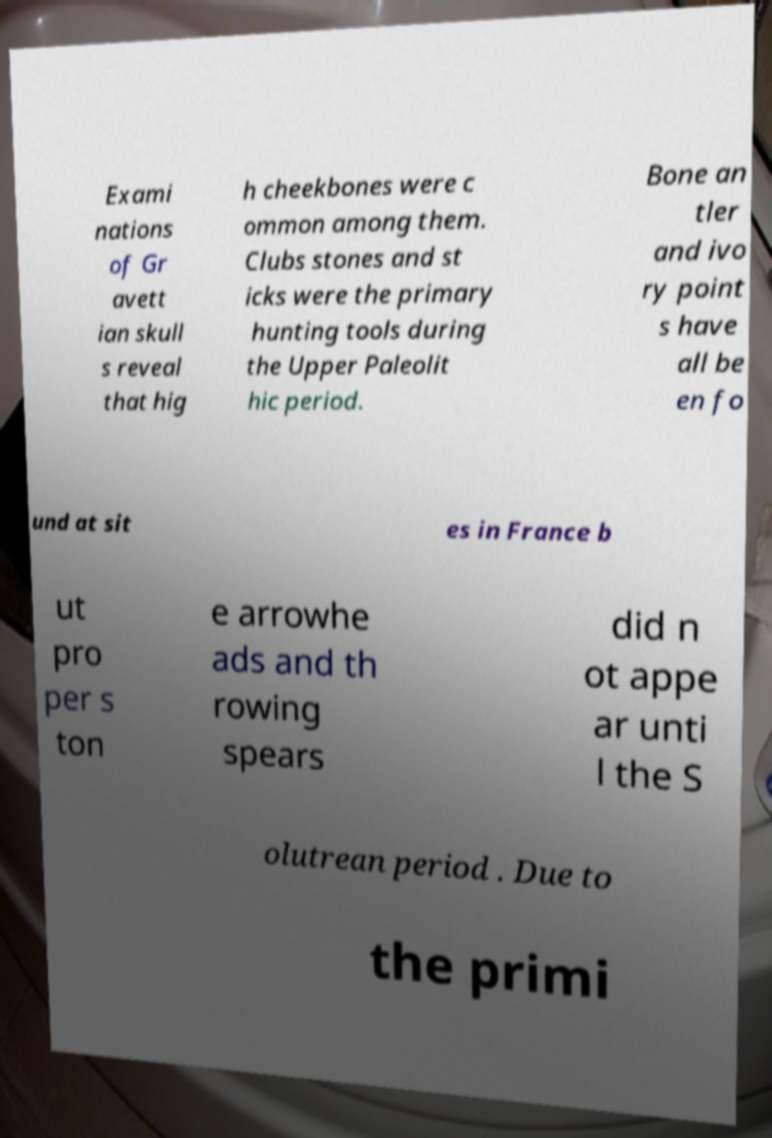Please identify and transcribe the text found in this image. Exami nations of Gr avett ian skull s reveal that hig h cheekbones were c ommon among them. Clubs stones and st icks were the primary hunting tools during the Upper Paleolit hic period. Bone an tler and ivo ry point s have all be en fo und at sit es in France b ut pro per s ton e arrowhe ads and th rowing spears did n ot appe ar unti l the S olutrean period . Due to the primi 